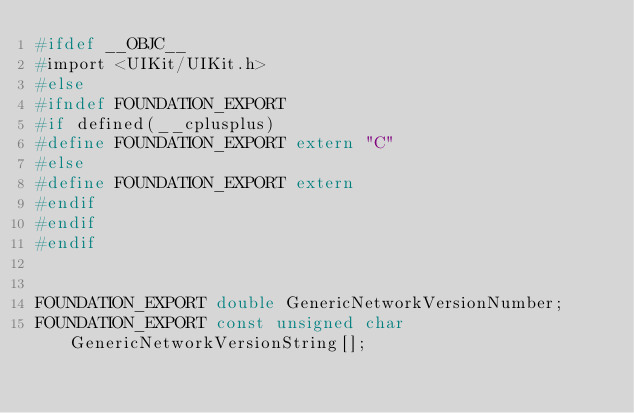Convert code to text. <code><loc_0><loc_0><loc_500><loc_500><_C_>#ifdef __OBJC__
#import <UIKit/UIKit.h>
#else
#ifndef FOUNDATION_EXPORT
#if defined(__cplusplus)
#define FOUNDATION_EXPORT extern "C"
#else
#define FOUNDATION_EXPORT extern
#endif
#endif
#endif


FOUNDATION_EXPORT double GenericNetworkVersionNumber;
FOUNDATION_EXPORT const unsigned char GenericNetworkVersionString[];

</code> 